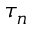<formula> <loc_0><loc_0><loc_500><loc_500>\tau _ { n }</formula> 